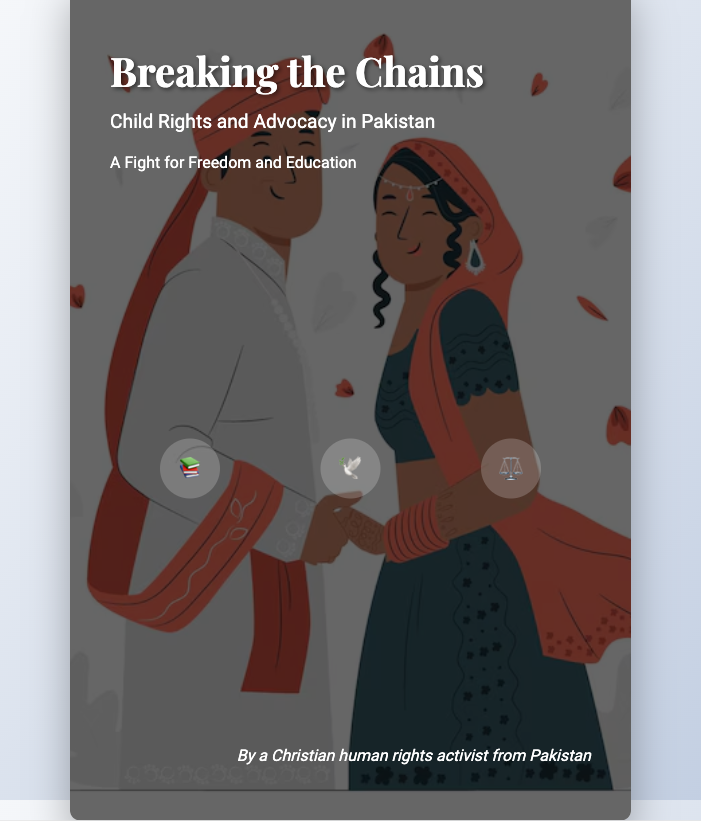what is the title of the book? The title is prominently displayed at the top of the cover as "Breaking the Chains".
Answer: Breaking the Chains what is the subtitle of the book? The subtitle is located beneath the title and reads "Child Rights and Advocacy in Pakistan".
Answer: Child Rights and Advocacy in Pakistan who is the author of the book? The author's name is mentioned at the bottom of the cover as "By a Christian human rights activist from Pakistan".
Answer: A Christian human rights activist from Pakistan what are the three themes represented on the cover? The themes are visually represented by icons and include education, freedom, and justice.
Answer: Education, Freedom, Justice what element surrounds the children in the cover design? The metaphorical representation shows children breaking free from chains, symbolizing their struggle for rights.
Answer: Chains what visual elements adorn the cover? The cover features images of children, chains, and thematic icons, symbolizing key ideas in the book.
Answer: Children, chains, thematic icons what is the main topic addressed in the book? The book focuses on the advocacy and rights of children, particularly in the context of Pakistan.
Answer: Child rights and advocacy how does the cover convey a sense of action or movement? The imagery of children breaking free from chains signifies liberation and progress.
Answer: Liberation and progress 